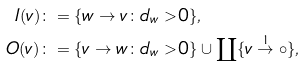<formula> <loc_0><loc_0><loc_500><loc_500>I ( v ) & \colon = \{ w \to v \colon d _ { w } > 0 \} , \\ O ( v ) & \colon = \{ v \to w \colon d _ { w } > 0 \} \cup \coprod \{ v \stackrel { 1 } { \to } \circ \} ,</formula> 